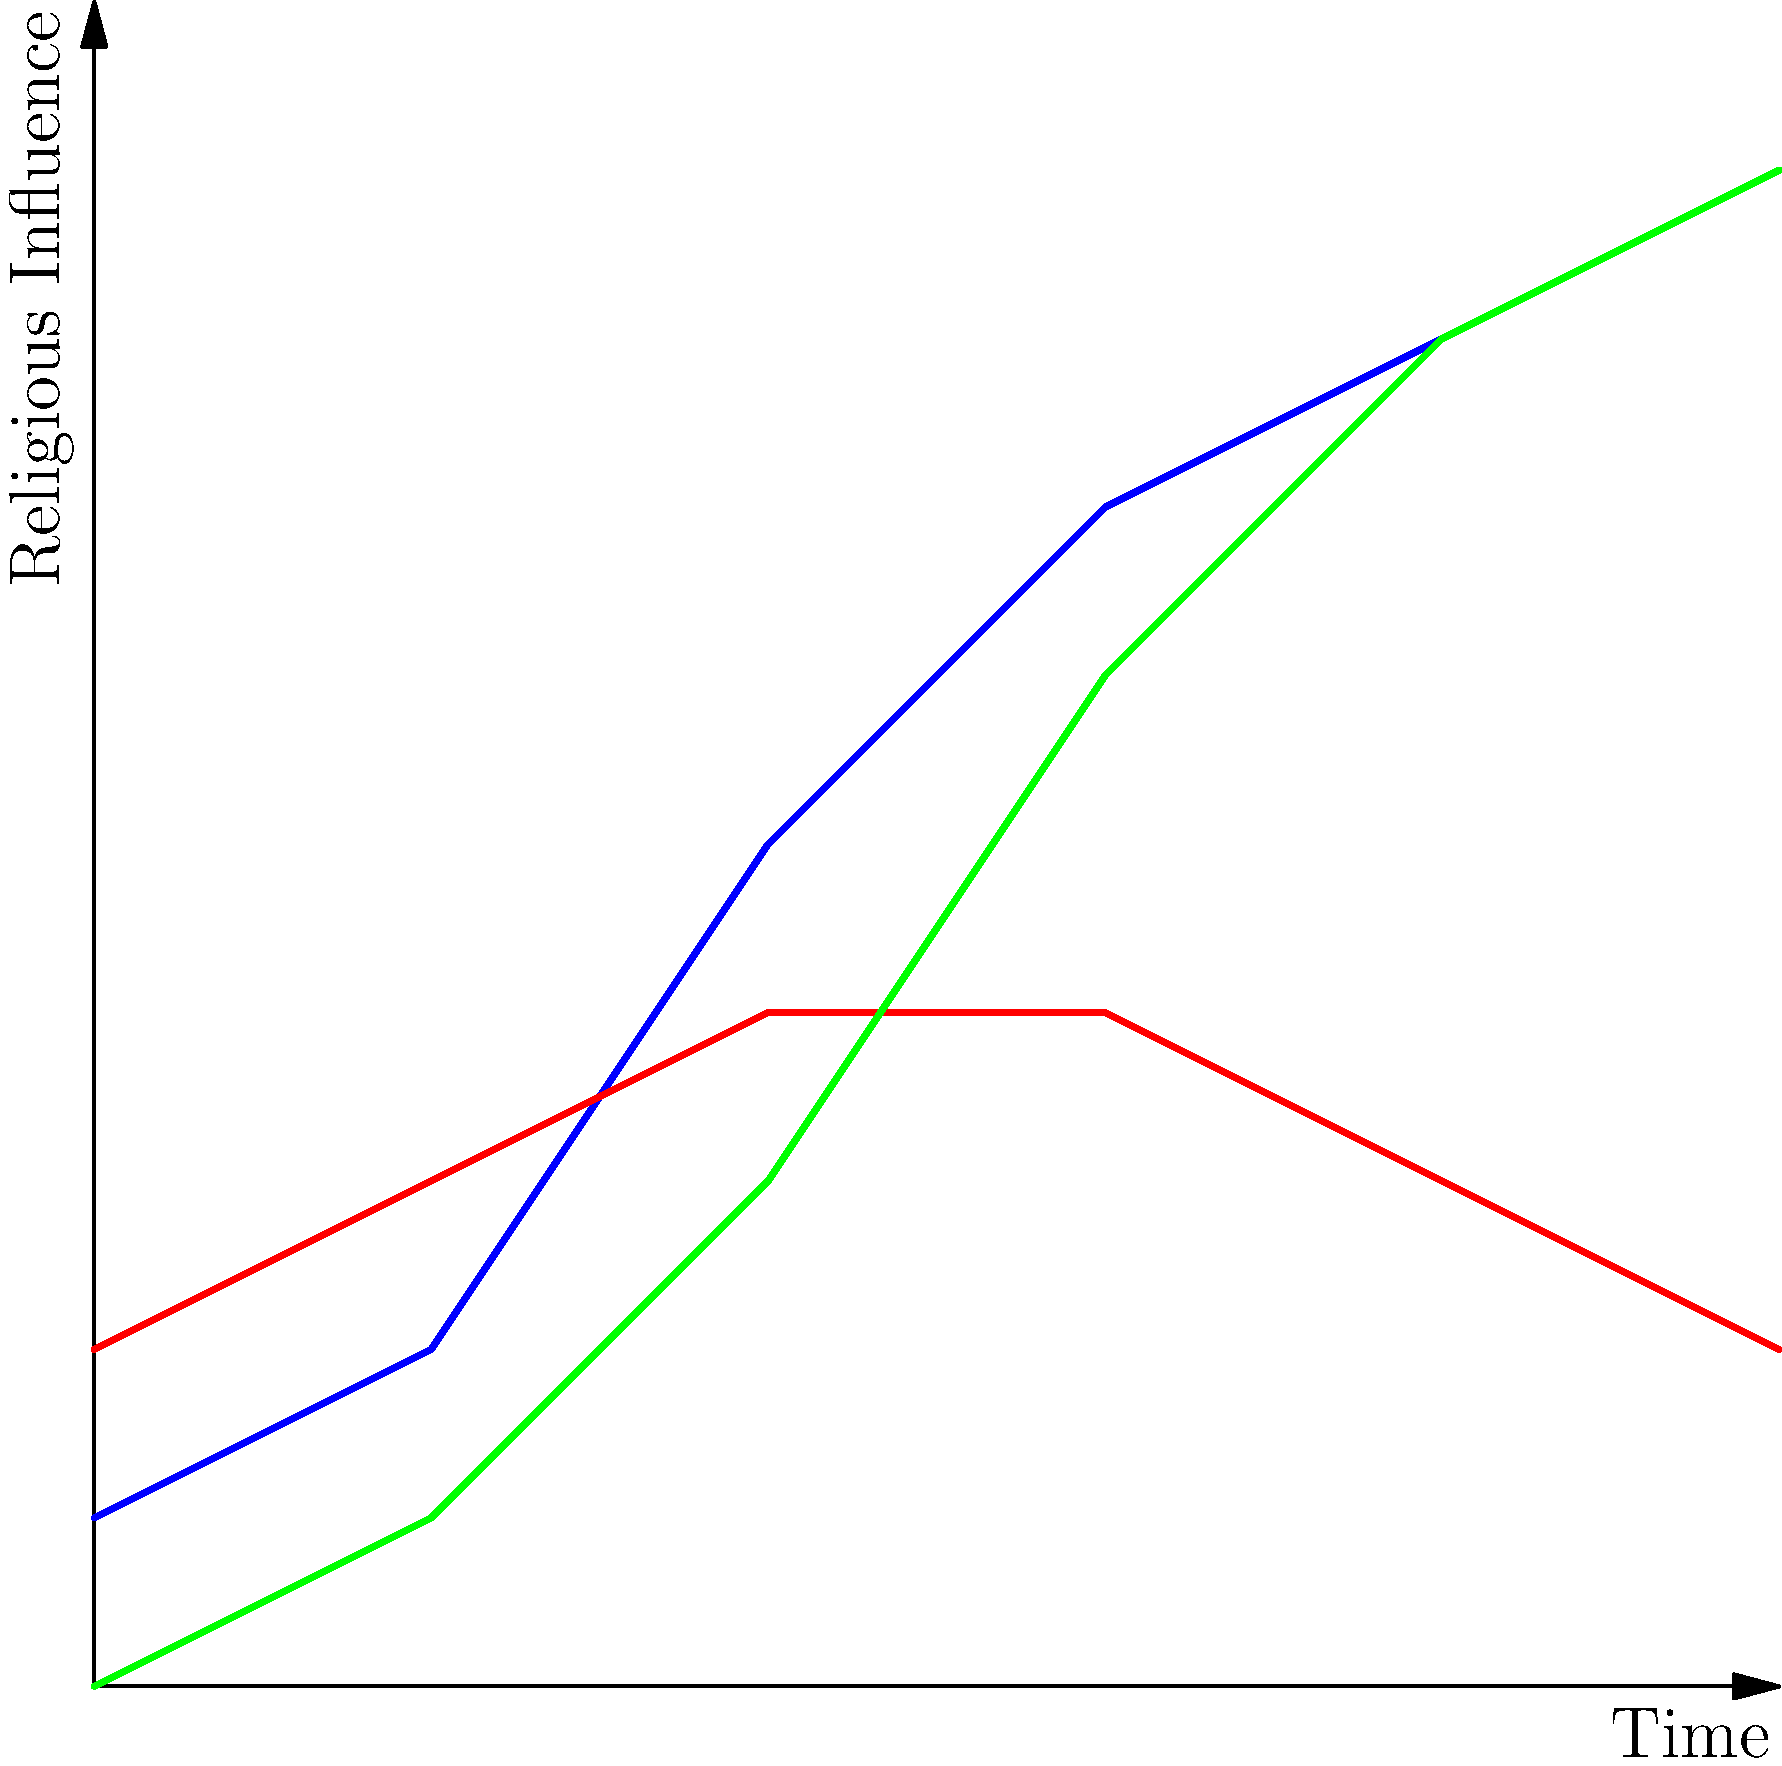Based on the geospatial data visualization of religious influence over time, which religion shows the most significant increase in influence from the beginning to the end of the observed period, and what historical factors might explain this trend? To answer this question, we need to analyze the graph and interpret the data:

1. Identify the religions:
   - Religion A: Blue line
   - Religion B: Red line
   - Religion C: Green line

2. Assess the change in influence for each religion:
   - Religion A: Starts at 1, ends at 9 (Increase of 8)
   - Religion B: Starts at 2, ends at 2 (No net change)
   - Religion C: Starts at 0, ends at 9 (Increase of 9)

3. Determine the religion with the most significant increase:
   Religion C shows the most significant increase, rising from 0 to 9.

4. Historical factors that might explain this trend:
   a) Missionary activity: Aggressive proselytization efforts
   b) Political support: Alignment with expanding empires or powerful states
   c) Cultural assimilation: Adaptation to local customs and beliefs
   d) Technological advancements: Improved communication and transportation
   e) Social and economic factors: Appeal to marginalized groups or economic benefits
   f) Charismatic leadership: Influential religious figures or reformers

5. Contextual analysis:
   The rapid rise of Religion C suggests a combination of these factors, possibly including a period of rapid expansion through conquest, effective missionary work, or significant socio-cultural changes that favored its spread.
Answer: Religion C; likely due to missionary activity, political support, cultural assimilation, technological advancements, social-economic factors, and charismatic leadership. 